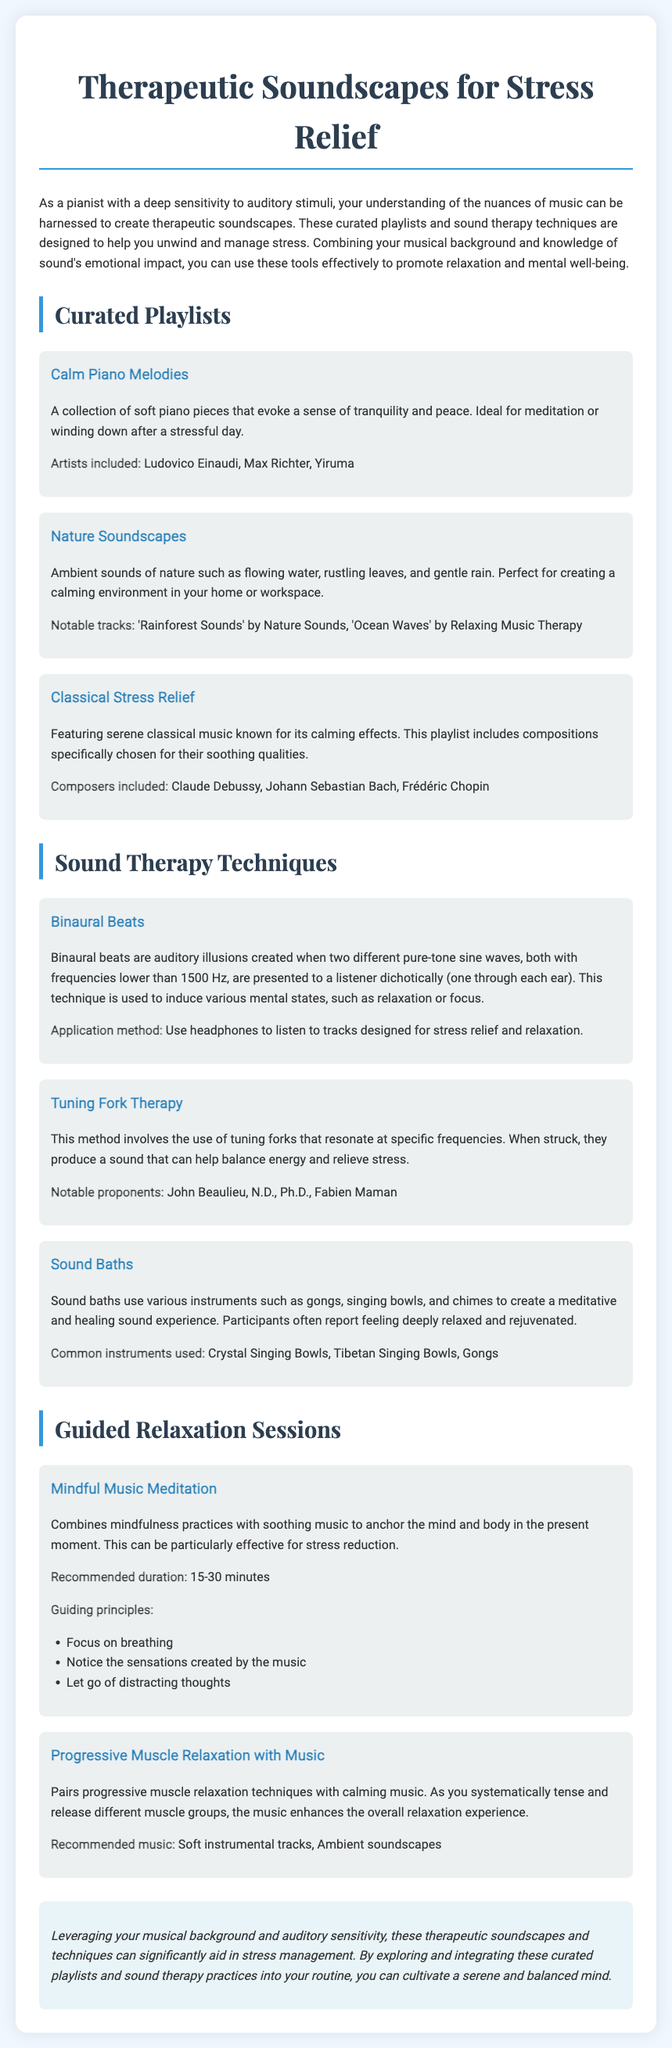What is the focus of the document? The document focuses on therapeutic soundscapes to help manage and relieve stress through music and sound therapy techniques.
Answer: Therapeutic soundscapes for stress relief Who are the artists included in the Calm Piano Melodies playlist? The artists mentioned for this playlist are specific musicians known for their calming piano music.
Answer: Ludovico Einaudi, Max Richter, Yiruma What method is used in Binaural Beats? Binaural beats create auditory illusions by using two different pure-tone sine waves presented separately to each ear.
Answer: Two different pure-tone sine waves What common instruments are used in Sound Baths? The document lists specific musical instruments that are typically used during sound bath sessions for relaxation.
Answer: Crystal Singing Bowls, Tibetan Singing Bowls, Gongs What is the recommended duration for Mindful Music Meditation? The document specifies a time frame during which this meditation practice should be conducted for maximum effectiveness.
Answer: 15-30 minutes What are the guiding principles of Mindful Music Meditation? The guiding principles listed in the document provide a framework for conducting this specific meditation type effectively.
Answer: Focus on breathing, Notice the sensations created by the music, Let go of distracting thoughts Which composers are included in the Classical Stress Relief playlist? The document details certain composers whose works are renowned for their calming properties and are featured in this playlist.
Answer: Claude Debussy, Johann Sebastian Bach, Frédéric Chopin What technique uses tuning forks for stress relief? This technique involves the utilization of specific frequency-producing tools to help alleviate stress and balance energy.
Answer: Tuning Fork Therapy What is the purpose of the Progressive Muscle Relaxation with Music? This method combines muscle relaxation techniques with music to enhance the overall relaxation experience for the listener.
Answer: Enhance overall relaxation experience 